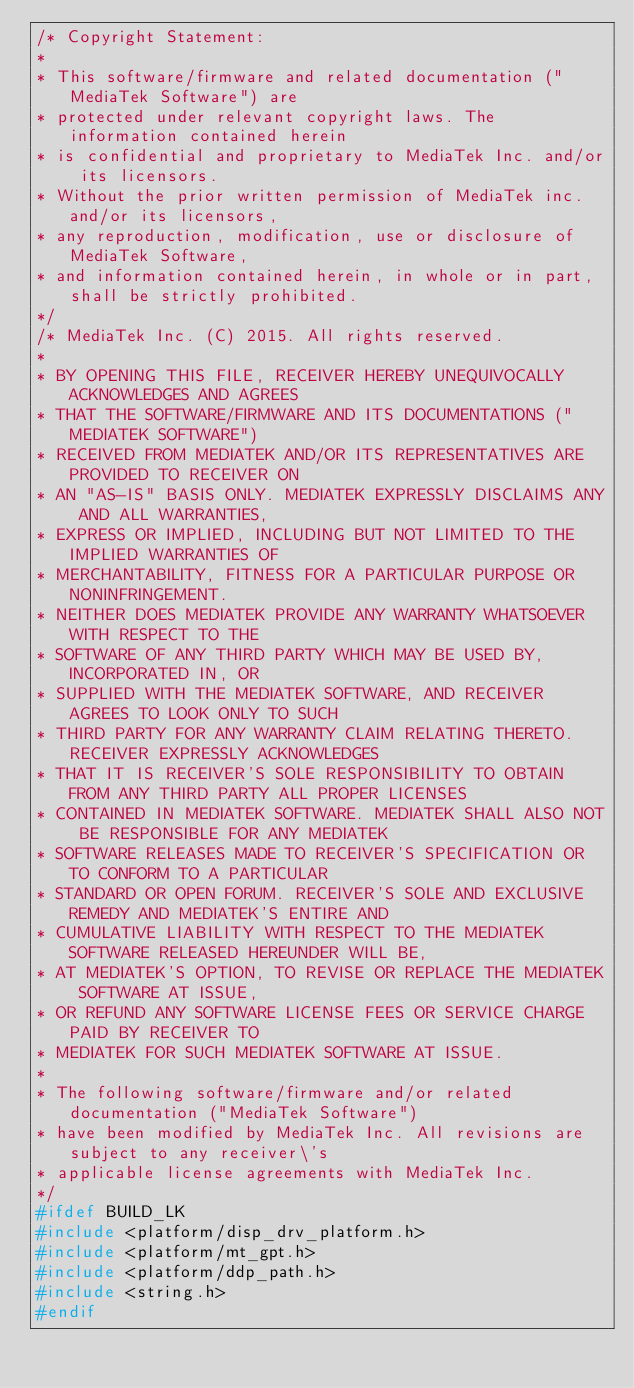<code> <loc_0><loc_0><loc_500><loc_500><_C_>/* Copyright Statement:
*
* This software/firmware and related documentation ("MediaTek Software") are
* protected under relevant copyright laws. The information contained herein
* is confidential and proprietary to MediaTek Inc. and/or its licensors.
* Without the prior written permission of MediaTek inc. and/or its licensors,
* any reproduction, modification, use or disclosure of MediaTek Software,
* and information contained herein, in whole or in part, shall be strictly prohibited.
*/
/* MediaTek Inc. (C) 2015. All rights reserved.
*
* BY OPENING THIS FILE, RECEIVER HEREBY UNEQUIVOCALLY ACKNOWLEDGES AND AGREES
* THAT THE SOFTWARE/FIRMWARE AND ITS DOCUMENTATIONS ("MEDIATEK SOFTWARE")
* RECEIVED FROM MEDIATEK AND/OR ITS REPRESENTATIVES ARE PROVIDED TO RECEIVER ON
* AN "AS-IS" BASIS ONLY. MEDIATEK EXPRESSLY DISCLAIMS ANY AND ALL WARRANTIES,
* EXPRESS OR IMPLIED, INCLUDING BUT NOT LIMITED TO THE IMPLIED WARRANTIES OF
* MERCHANTABILITY, FITNESS FOR A PARTICULAR PURPOSE OR NONINFRINGEMENT.
* NEITHER DOES MEDIATEK PROVIDE ANY WARRANTY WHATSOEVER WITH RESPECT TO THE
* SOFTWARE OF ANY THIRD PARTY WHICH MAY BE USED BY, INCORPORATED IN, OR
* SUPPLIED WITH THE MEDIATEK SOFTWARE, AND RECEIVER AGREES TO LOOK ONLY TO SUCH
* THIRD PARTY FOR ANY WARRANTY CLAIM RELATING THERETO. RECEIVER EXPRESSLY ACKNOWLEDGES
* THAT IT IS RECEIVER'S SOLE RESPONSIBILITY TO OBTAIN FROM ANY THIRD PARTY ALL PROPER LICENSES
* CONTAINED IN MEDIATEK SOFTWARE. MEDIATEK SHALL ALSO NOT BE RESPONSIBLE FOR ANY MEDIATEK
* SOFTWARE RELEASES MADE TO RECEIVER'S SPECIFICATION OR TO CONFORM TO A PARTICULAR
* STANDARD OR OPEN FORUM. RECEIVER'S SOLE AND EXCLUSIVE REMEDY AND MEDIATEK'S ENTIRE AND
* CUMULATIVE LIABILITY WITH RESPECT TO THE MEDIATEK SOFTWARE RELEASED HEREUNDER WILL BE,
* AT MEDIATEK'S OPTION, TO REVISE OR REPLACE THE MEDIATEK SOFTWARE AT ISSUE,
* OR REFUND ANY SOFTWARE LICENSE FEES OR SERVICE CHARGE PAID BY RECEIVER TO
* MEDIATEK FOR SUCH MEDIATEK SOFTWARE AT ISSUE.
*
* The following software/firmware and/or related documentation ("MediaTek Software")
* have been modified by MediaTek Inc. All revisions are subject to any receiver\'s
* applicable license agreements with MediaTek Inc.
*/
#ifdef BUILD_LK
#include <platform/disp_drv_platform.h>
#include <platform/mt_gpt.h>
#include <platform/ddp_path.h>
#include <string.h>
#endif

</code> 